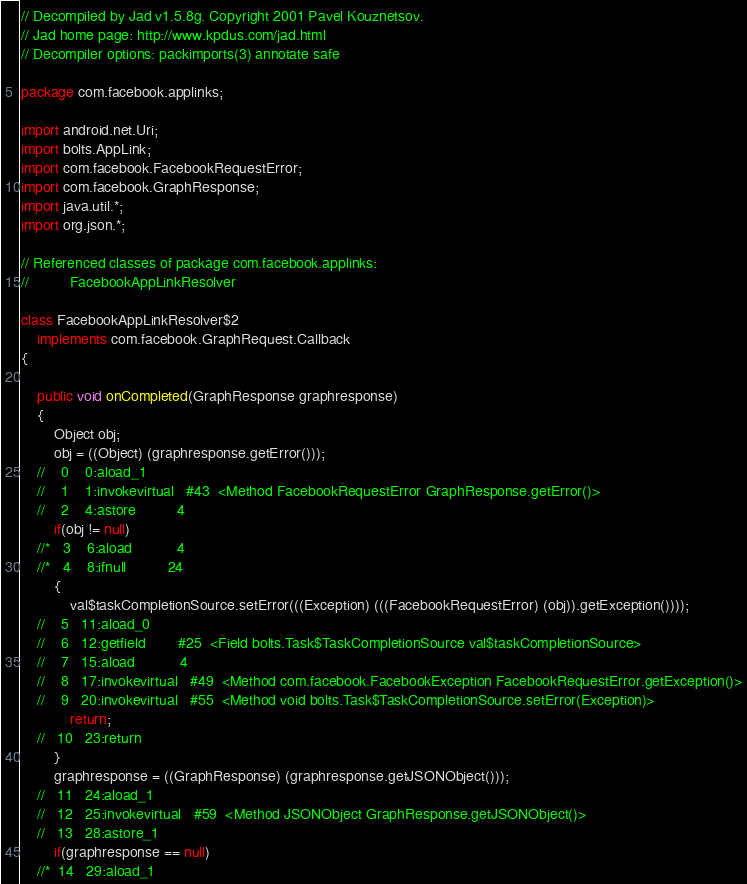<code> <loc_0><loc_0><loc_500><loc_500><_Java_>// Decompiled by Jad v1.5.8g. Copyright 2001 Pavel Kouznetsov.
// Jad home page: http://www.kpdus.com/jad.html
// Decompiler options: packimports(3) annotate safe 

package com.facebook.applinks;

import android.net.Uri;
import bolts.AppLink;
import com.facebook.FacebookRequestError;
import com.facebook.GraphResponse;
import java.util.*;
import org.json.*;

// Referenced classes of package com.facebook.applinks:
//			FacebookAppLinkResolver

class FacebookAppLinkResolver$2
	implements com.facebook.GraphRequest.Callback
{

	public void onCompleted(GraphResponse graphresponse)
	{
		Object obj;
		obj = ((Object) (graphresponse.getError()));
	//    0    0:aload_1         
	//    1    1:invokevirtual   #43  <Method FacebookRequestError GraphResponse.getError()>
	//    2    4:astore          4
		if(obj != null)
	//*   3    6:aload           4
	//*   4    8:ifnull          24
		{
			val$taskCompletionSource.setError(((Exception) (((FacebookRequestError) (obj)).getException())));
	//    5   11:aload_0         
	//    6   12:getfield        #25  <Field bolts.Task$TaskCompletionSource val$taskCompletionSource>
	//    7   15:aload           4
	//    8   17:invokevirtual   #49  <Method com.facebook.FacebookException FacebookRequestError.getException()>
	//    9   20:invokevirtual   #55  <Method void bolts.Task$TaskCompletionSource.setError(Exception)>
			return;
	//   10   23:return          
		}
		graphresponse = ((GraphResponse) (graphresponse.getJSONObject()));
	//   11   24:aload_1         
	//   12   25:invokevirtual   #59  <Method JSONObject GraphResponse.getJSONObject()>
	//   13   28:astore_1        
		if(graphresponse == null)
	//*  14   29:aload_1         </code> 